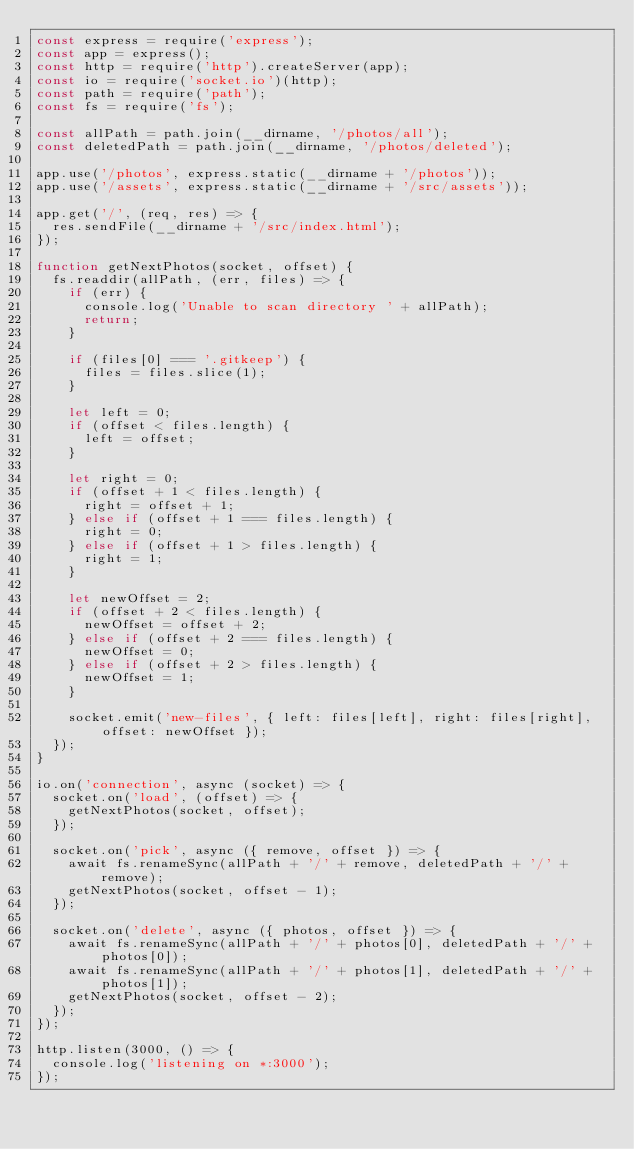<code> <loc_0><loc_0><loc_500><loc_500><_JavaScript_>const express = require('express');
const app = express();
const http = require('http').createServer(app);
const io = require('socket.io')(http);
const path = require('path');
const fs = require('fs');

const allPath = path.join(__dirname, '/photos/all');
const deletedPath = path.join(__dirname, '/photos/deleted');

app.use('/photos', express.static(__dirname + '/photos'));
app.use('/assets', express.static(__dirname + '/src/assets'));

app.get('/', (req, res) => {
  res.sendFile(__dirname + '/src/index.html');
});

function getNextPhotos(socket, offset) {
  fs.readdir(allPath, (err, files) => {
    if (err) {
      console.log('Unable to scan directory ' + allPath);
      return;
    }

    if (files[0] === '.gitkeep') {
      files = files.slice(1);
    }

    let left = 0;
    if (offset < files.length) {
      left = offset;
    }

    let right = 0;
    if (offset + 1 < files.length) {
      right = offset + 1;
    } else if (offset + 1 === files.length) {
      right = 0;
    } else if (offset + 1 > files.length) {
      right = 1;
    }

    let newOffset = 2;
    if (offset + 2 < files.length) {
      newOffset = offset + 2;
    } else if (offset + 2 === files.length) {
      newOffset = 0;
    } else if (offset + 2 > files.length) {
      newOffset = 1;
    }

    socket.emit('new-files', { left: files[left], right: files[right], offset: newOffset });
  });
}

io.on('connection', async (socket) => {
  socket.on('load', (offset) => {
    getNextPhotos(socket, offset);
  });

  socket.on('pick', async ({ remove, offset }) => {
    await fs.renameSync(allPath + '/' + remove, deletedPath + '/' + remove);
    getNextPhotos(socket, offset - 1);
  });

  socket.on('delete', async ({ photos, offset }) => {
    await fs.renameSync(allPath + '/' + photos[0], deletedPath + '/' + photos[0]);
    await fs.renameSync(allPath + '/' + photos[1], deletedPath + '/' + photos[1]);
    getNextPhotos(socket, offset - 2);
  });
});

http.listen(3000, () => {
  console.log('listening on *:3000');
});
</code> 